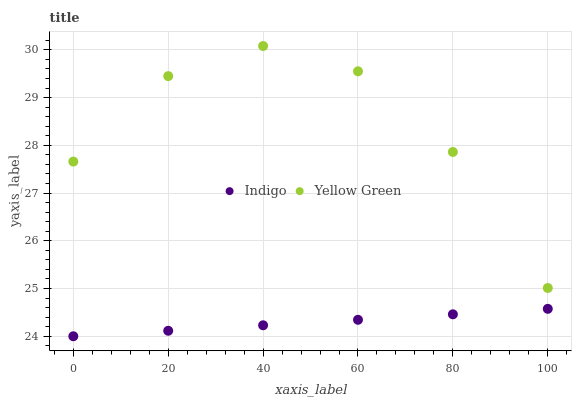Does Indigo have the minimum area under the curve?
Answer yes or no. Yes. Does Yellow Green have the maximum area under the curve?
Answer yes or no. Yes. Does Yellow Green have the minimum area under the curve?
Answer yes or no. No. Is Indigo the smoothest?
Answer yes or no. Yes. Is Yellow Green the roughest?
Answer yes or no. Yes. Is Yellow Green the smoothest?
Answer yes or no. No. Does Indigo have the lowest value?
Answer yes or no. Yes. Does Yellow Green have the lowest value?
Answer yes or no. No. Does Yellow Green have the highest value?
Answer yes or no. Yes. Is Indigo less than Yellow Green?
Answer yes or no. Yes. Is Yellow Green greater than Indigo?
Answer yes or no. Yes. Does Indigo intersect Yellow Green?
Answer yes or no. No. 